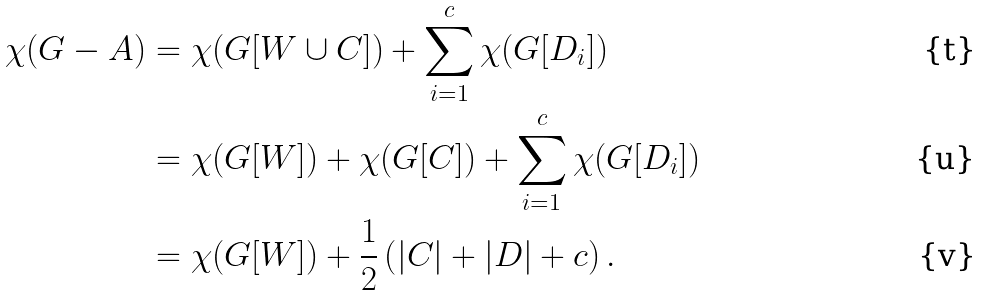Convert formula to latex. <formula><loc_0><loc_0><loc_500><loc_500>\chi ( G - A ) & = \chi ( G [ W \cup C ] ) + \sum _ { i = 1 } ^ { c } \chi ( G [ D _ { i } ] ) \\ & = \chi ( G [ W ] ) + \chi ( G [ C ] ) + \sum _ { i = 1 } ^ { c } \chi ( G [ D _ { i } ] ) \\ & = \chi ( G [ W ] ) + \frac { 1 } { 2 } \left ( | C | + | D | + c \right ) .</formula> 